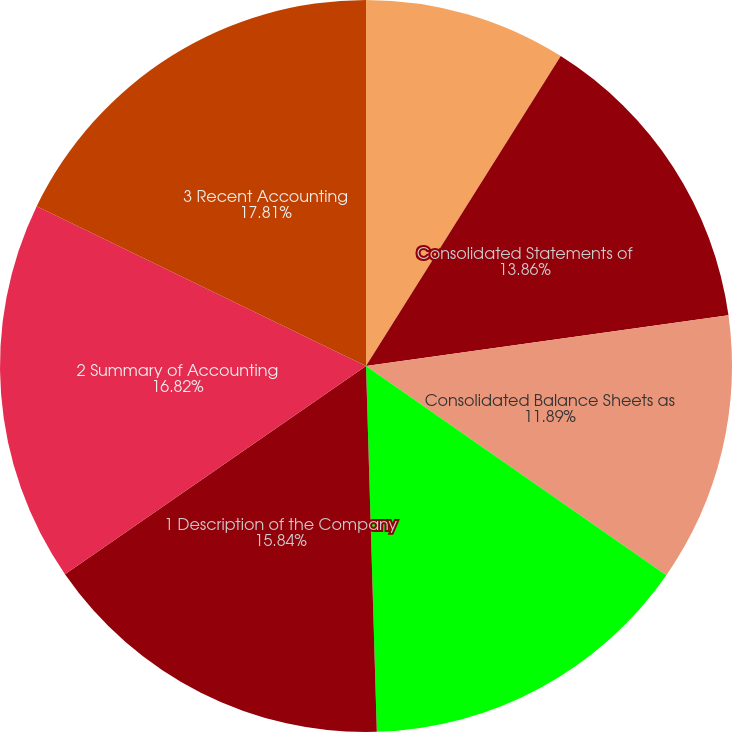<chart> <loc_0><loc_0><loc_500><loc_500><pie_chart><fcel>Report of Independent<fcel>Consolidated Statements of<fcel>Consolidated Balance Sheets as<fcel>Notes to the Consolidated<fcel>1 Description of the Company<fcel>2 Summary of Accounting<fcel>3 Recent Accounting<nl><fcel>8.93%<fcel>13.86%<fcel>11.89%<fcel>14.85%<fcel>15.84%<fcel>16.82%<fcel>17.81%<nl></chart> 